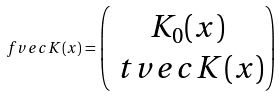<formula> <loc_0><loc_0><loc_500><loc_500>\ f v e c { K } ( x ) = \begin{pmatrix} K _ { 0 } ( x ) \\ \ t v e c { K } ( x ) \end{pmatrix}</formula> 